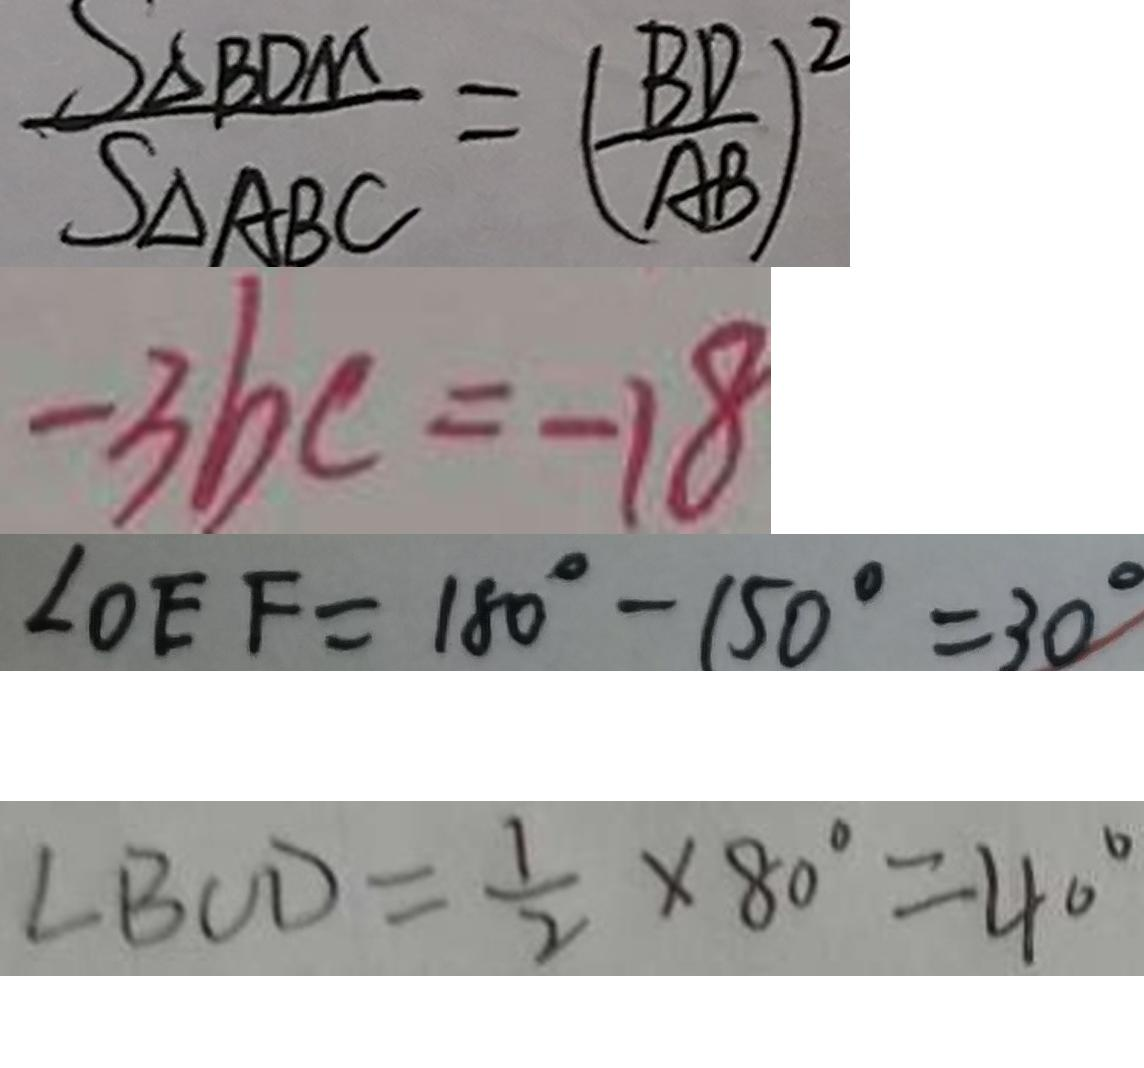<formula> <loc_0><loc_0><loc_500><loc_500>\frac { S _ { \Delta B D M } } { S _ { \Delta A B C } } = ( \frac { B D } { A B } ) ^ { 2 } 
 - 3 b c = - 1 8 
 \angle O E F = 1 8 0 ^ { \circ } - 1 5 0 ^ { \circ } = 3 0 ^ { \circ } 
 \angle B C D = \frac { 1 } { 2 } \times 8 0 ^ { \circ } = 4 0 ^ { \circ }</formula> 